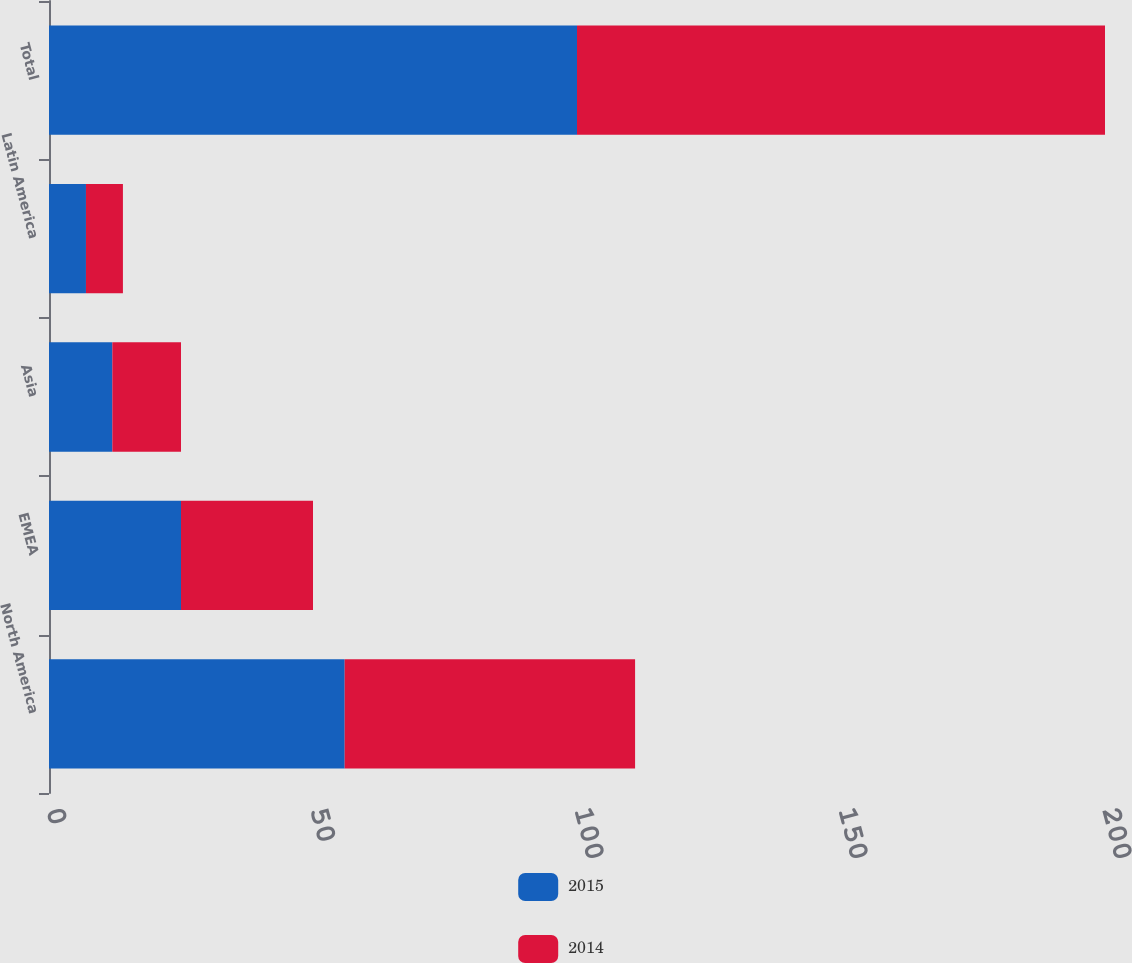Convert chart. <chart><loc_0><loc_0><loc_500><loc_500><stacked_bar_chart><ecel><fcel>North America<fcel>EMEA<fcel>Asia<fcel>Latin America<fcel>Total<nl><fcel>2015<fcel>56<fcel>25<fcel>12<fcel>7<fcel>100<nl><fcel>2014<fcel>55<fcel>25<fcel>13<fcel>7<fcel>100<nl></chart> 